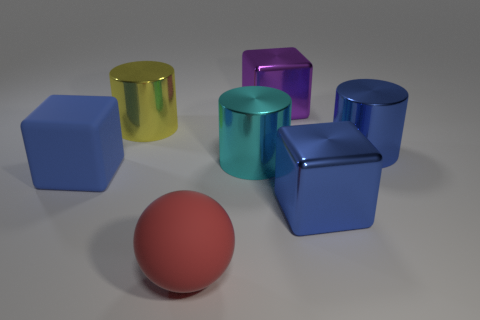Subtract all big cyan cylinders. How many cylinders are left? 2 Subtract 2 cylinders. How many cylinders are left? 1 Subtract all gray spheres. How many blue blocks are left? 2 Subtract all blue cylinders. How many cylinders are left? 2 Add 1 big yellow cylinders. How many objects exist? 8 Subtract all spheres. How many objects are left? 6 Add 4 matte spheres. How many matte spheres are left? 5 Add 6 cyan things. How many cyan things exist? 7 Subtract 1 blue cylinders. How many objects are left? 6 Subtract all cyan blocks. Subtract all gray spheres. How many blocks are left? 3 